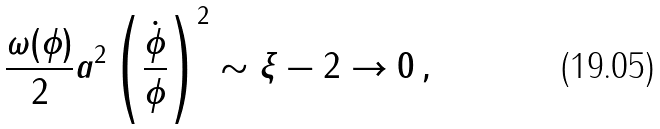Convert formula to latex. <formula><loc_0><loc_0><loc_500><loc_500>\frac { \omega ( \phi ) } { 2 } a ^ { 2 } \left ( \frac { \dot { \phi } } { \phi } \right ) ^ { 2 } \sim \xi - 2 \rightarrow 0 \, ,</formula> 